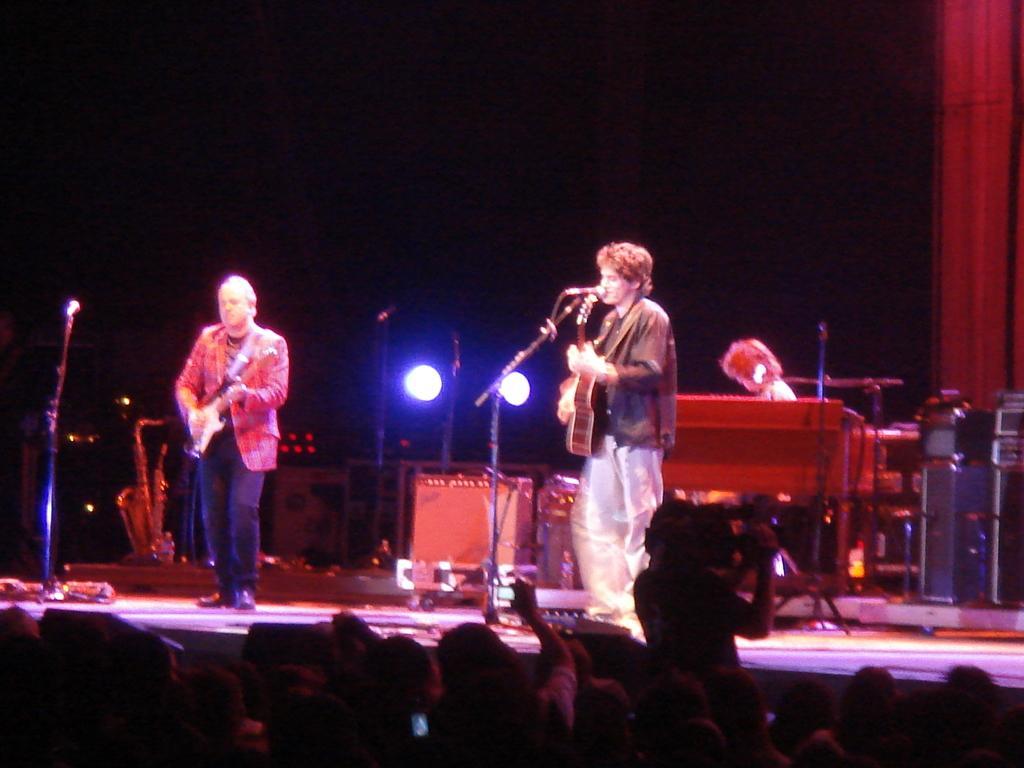Describe this image in one or two sentences. On this stage persons are playing musical instruments. Far there is a focusing light. These are audience. 